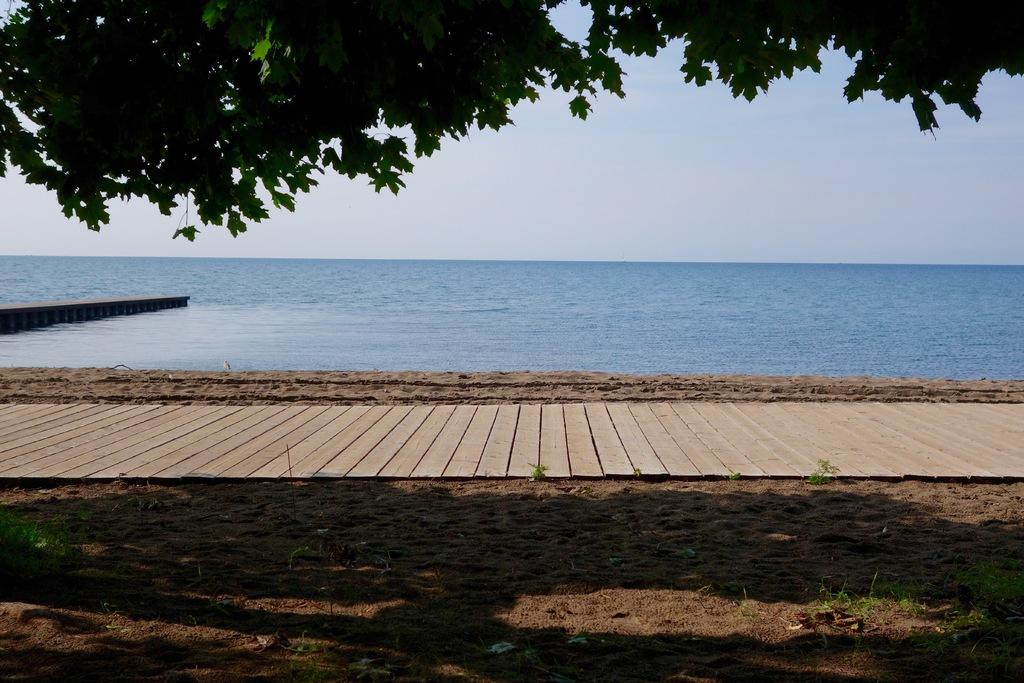What type of vegetation can be seen in the image? There are trees in the image. What color are the trees? The trees are green. What else can be seen besides the trees in the image? There is water and sky visible in the image. What color is the water? The water is blue. What color is the sky? The sky is blue. Reasoning: Let'ing: Let's think step by step in order to produce the conversation. We start by identifying the main subject in the image, which is the trees. Then, we describe their color and expand the conversation to include other elements visible in the image, such as water and sky. Each question is designed to elicit a specific detail about the image that is known from the provided facts. Absurd Question/Answer: What type of vegetable is being used to create a thrilling learning experience in the image? There is no vegetable or learning experience present in the image; it features trees, water, and sky. 